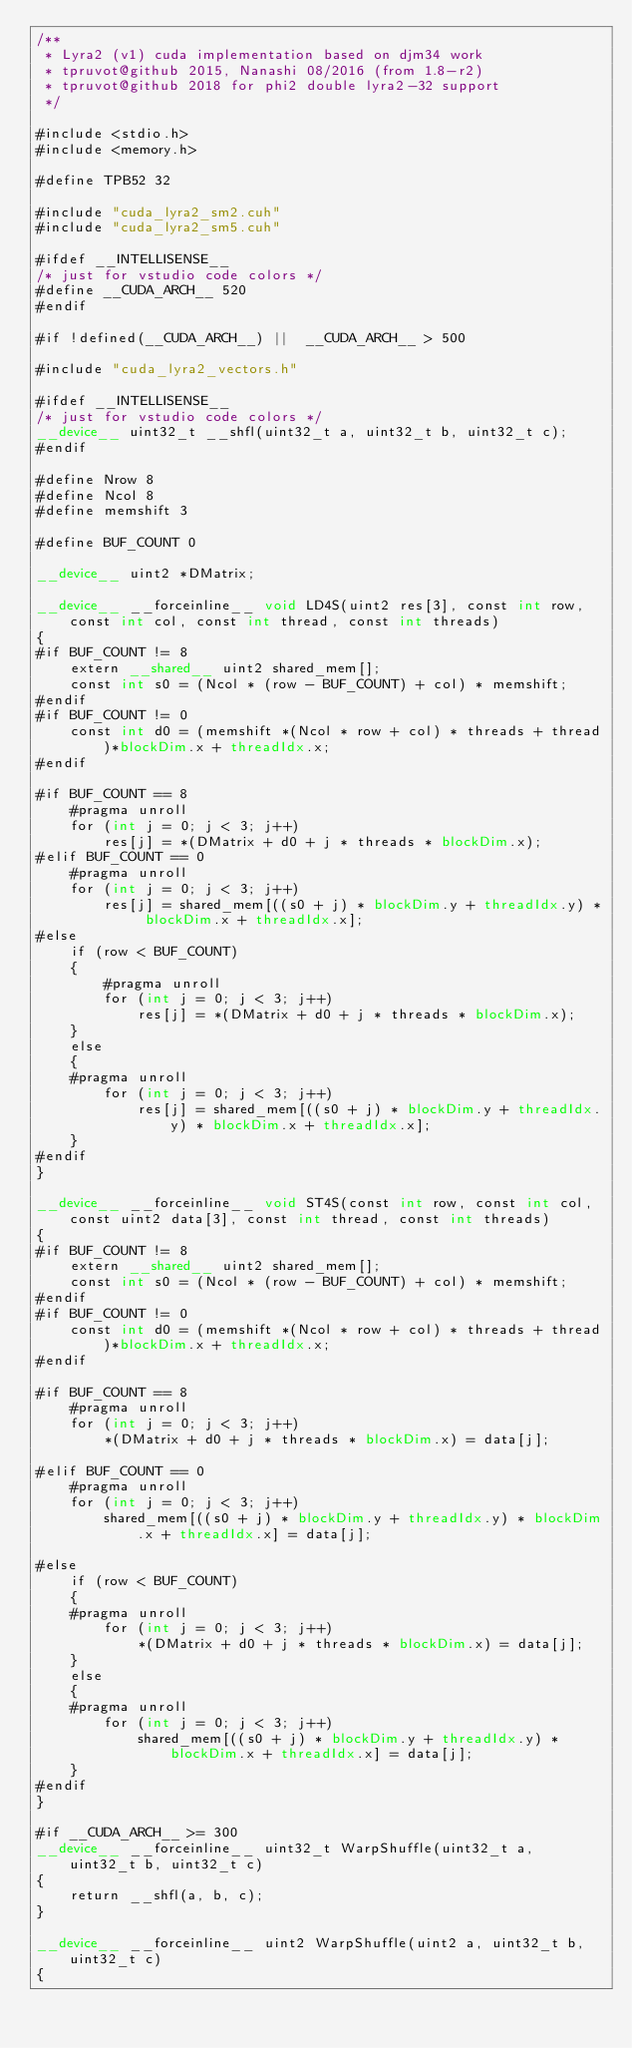Convert code to text. <code><loc_0><loc_0><loc_500><loc_500><_Cuda_>/**
 * Lyra2 (v1) cuda implementation based on djm34 work
 * tpruvot@github 2015, Nanashi 08/2016 (from 1.8-r2)
 * tpruvot@github 2018 for phi2 double lyra2-32 support
 */

#include <stdio.h>
#include <memory.h>

#define TPB52 32

#include "cuda_lyra2_sm2.cuh"
#include "cuda_lyra2_sm5.cuh"

#ifdef __INTELLISENSE__
/* just for vstudio code colors */
#define __CUDA_ARCH__ 520
#endif

#if !defined(__CUDA_ARCH__) ||  __CUDA_ARCH__ > 500

#include "cuda_lyra2_vectors.h"

#ifdef __INTELLISENSE__
/* just for vstudio code colors */
__device__ uint32_t __shfl(uint32_t a, uint32_t b, uint32_t c);
#endif

#define Nrow 8
#define Ncol 8
#define memshift 3

#define BUF_COUNT 0

__device__ uint2 *DMatrix;

__device__ __forceinline__ void LD4S(uint2 res[3], const int row, const int col, const int thread, const int threads)
{
#if BUF_COUNT != 8
	extern __shared__ uint2 shared_mem[];
	const int s0 = (Ncol * (row - BUF_COUNT) + col) * memshift;
#endif
#if BUF_COUNT != 0
	const int d0 = (memshift *(Ncol * row + col) * threads + thread)*blockDim.x + threadIdx.x;
#endif

#if BUF_COUNT == 8
	#pragma unroll
	for (int j = 0; j < 3; j++)
		res[j] = *(DMatrix + d0 + j * threads * blockDim.x);
#elif BUF_COUNT == 0
	#pragma unroll
	for (int j = 0; j < 3; j++)
		res[j] = shared_mem[((s0 + j) * blockDim.y + threadIdx.y) * blockDim.x + threadIdx.x];
#else
	if (row < BUF_COUNT)
	{
		#pragma unroll
		for (int j = 0; j < 3; j++)
			res[j] = *(DMatrix + d0 + j * threads * blockDim.x);
	}
	else
	{
	#pragma unroll
		for (int j = 0; j < 3; j++)
			res[j] = shared_mem[((s0 + j) * blockDim.y + threadIdx.y) * blockDim.x + threadIdx.x];
	}
#endif
}

__device__ __forceinline__ void ST4S(const int row, const int col, const uint2 data[3], const int thread, const int threads)
{
#if BUF_COUNT != 8
	extern __shared__ uint2 shared_mem[];
	const int s0 = (Ncol * (row - BUF_COUNT) + col) * memshift;
#endif
#if BUF_COUNT != 0
	const int d0 = (memshift *(Ncol * row + col) * threads + thread)*blockDim.x + threadIdx.x;
#endif

#if BUF_COUNT == 8
	#pragma unroll
	for (int j = 0; j < 3; j++)
		*(DMatrix + d0 + j * threads * blockDim.x) = data[j];

#elif BUF_COUNT == 0
	#pragma unroll
	for (int j = 0; j < 3; j++)
		shared_mem[((s0 + j) * blockDim.y + threadIdx.y) * blockDim.x + threadIdx.x] = data[j];

#else
	if (row < BUF_COUNT)
	{
	#pragma unroll
		for (int j = 0; j < 3; j++)
			*(DMatrix + d0 + j * threads * blockDim.x) = data[j];
	}
	else
	{
	#pragma unroll
		for (int j = 0; j < 3; j++)
			shared_mem[((s0 + j) * blockDim.y + threadIdx.y) * blockDim.x + threadIdx.x] = data[j];
	}
#endif
}

#if __CUDA_ARCH__ >= 300
__device__ __forceinline__ uint32_t WarpShuffle(uint32_t a, uint32_t b, uint32_t c)
{
	return __shfl(a, b, c);
}

__device__ __forceinline__ uint2 WarpShuffle(uint2 a, uint32_t b, uint32_t c)
{</code> 